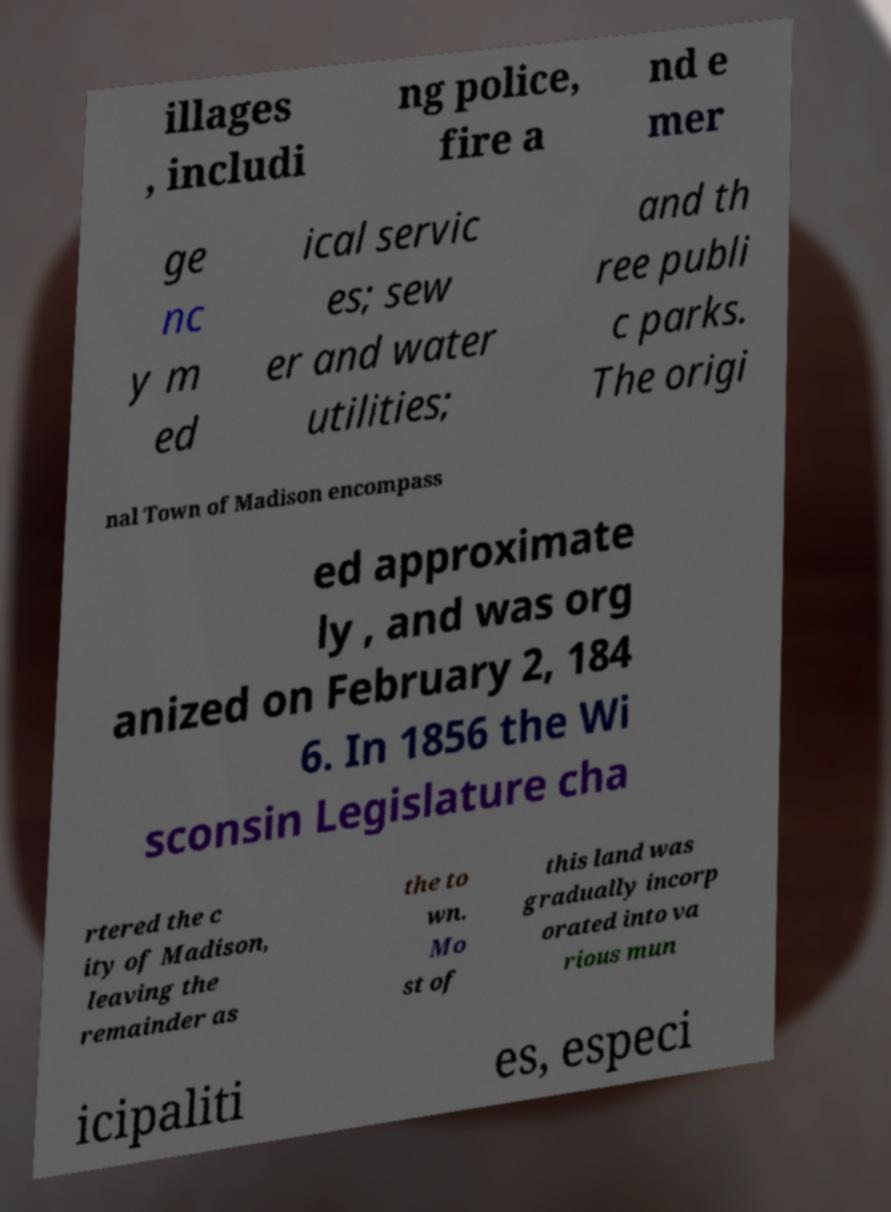Could you assist in decoding the text presented in this image and type it out clearly? illages , includi ng police, fire a nd e mer ge nc y m ed ical servic es; sew er and water utilities; and th ree publi c parks. The origi nal Town of Madison encompass ed approximate ly , and was org anized on February 2, 184 6. In 1856 the Wi sconsin Legislature cha rtered the c ity of Madison, leaving the remainder as the to wn. Mo st of this land was gradually incorp orated into va rious mun icipaliti es, especi 